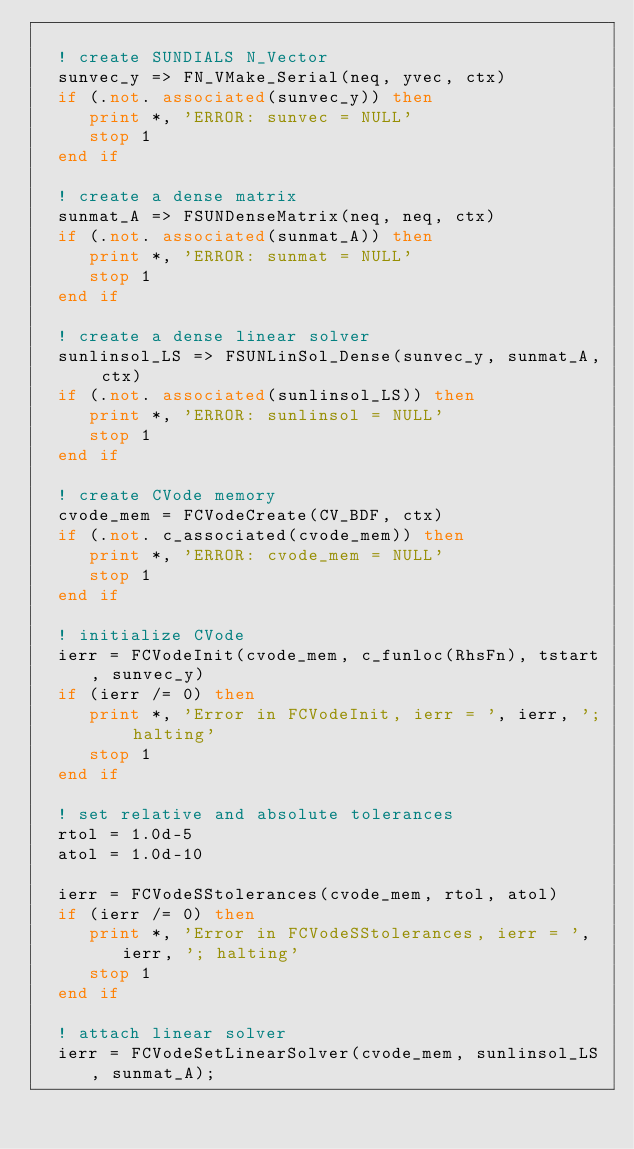<code> <loc_0><loc_0><loc_500><loc_500><_FORTRAN_>
  ! create SUNDIALS N_Vector
  sunvec_y => FN_VMake_Serial(neq, yvec, ctx)
  if (.not. associated(sunvec_y)) then
     print *, 'ERROR: sunvec = NULL'
     stop 1
  end if

  ! create a dense matrix
  sunmat_A => FSUNDenseMatrix(neq, neq, ctx)
  if (.not. associated(sunmat_A)) then
     print *, 'ERROR: sunmat = NULL'
     stop 1
  end if

  ! create a dense linear solver
  sunlinsol_LS => FSUNLinSol_Dense(sunvec_y, sunmat_A, ctx)
  if (.not. associated(sunlinsol_LS)) then
     print *, 'ERROR: sunlinsol = NULL'
     stop 1
  end if

  ! create CVode memory
  cvode_mem = FCVodeCreate(CV_BDF, ctx)
  if (.not. c_associated(cvode_mem)) then
     print *, 'ERROR: cvode_mem = NULL'
     stop 1
  end if

  ! initialize CVode
  ierr = FCVodeInit(cvode_mem, c_funloc(RhsFn), tstart, sunvec_y)
  if (ierr /= 0) then
     print *, 'Error in FCVodeInit, ierr = ', ierr, '; halting'
     stop 1
  end if

  ! set relative and absolute tolerances
  rtol = 1.0d-5
  atol = 1.0d-10

  ierr = FCVodeSStolerances(cvode_mem, rtol, atol)
  if (ierr /= 0) then
     print *, 'Error in FCVodeSStolerances, ierr = ', ierr, '; halting'
     stop 1
  end if

  ! attach linear solver
  ierr = FCVodeSetLinearSolver(cvode_mem, sunlinsol_LS, sunmat_A);</code> 